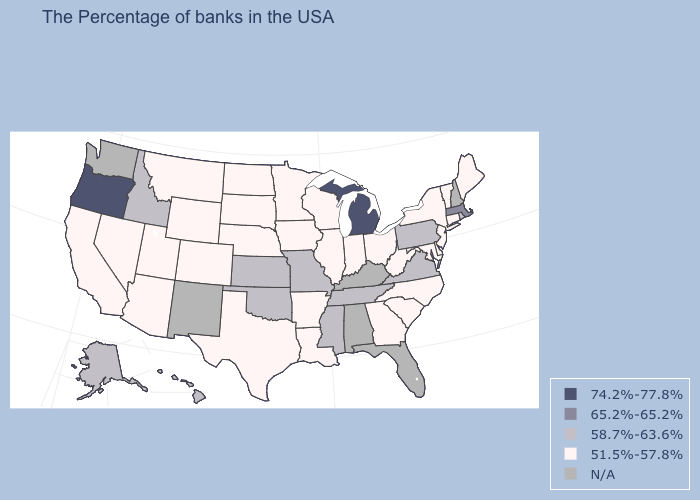Does Connecticut have the lowest value in the USA?
Concise answer only. Yes. Which states have the highest value in the USA?
Keep it brief. Michigan, Oregon. Among the states that border Iowa , which have the highest value?
Be succinct. Missouri. Does the first symbol in the legend represent the smallest category?
Short answer required. No. What is the highest value in the MidWest ?
Quick response, please. 74.2%-77.8%. Does Wyoming have the lowest value in the West?
Keep it brief. Yes. What is the highest value in the West ?
Answer briefly. 74.2%-77.8%. What is the highest value in the USA?
Quick response, please. 74.2%-77.8%. What is the value of Rhode Island?
Keep it brief. 58.7%-63.6%. Name the states that have a value in the range 74.2%-77.8%?
Write a very short answer. Michigan, Oregon. What is the value of Rhode Island?
Concise answer only. 58.7%-63.6%. What is the value of North Dakota?
Concise answer only. 51.5%-57.8%. Does Colorado have the lowest value in the USA?
Keep it brief. Yes. Name the states that have a value in the range 51.5%-57.8%?
Keep it brief. Maine, Vermont, Connecticut, New York, New Jersey, Delaware, Maryland, North Carolina, South Carolina, West Virginia, Ohio, Georgia, Indiana, Wisconsin, Illinois, Louisiana, Arkansas, Minnesota, Iowa, Nebraska, Texas, South Dakota, North Dakota, Wyoming, Colorado, Utah, Montana, Arizona, Nevada, California. What is the value of Mississippi?
Write a very short answer. 58.7%-63.6%. 